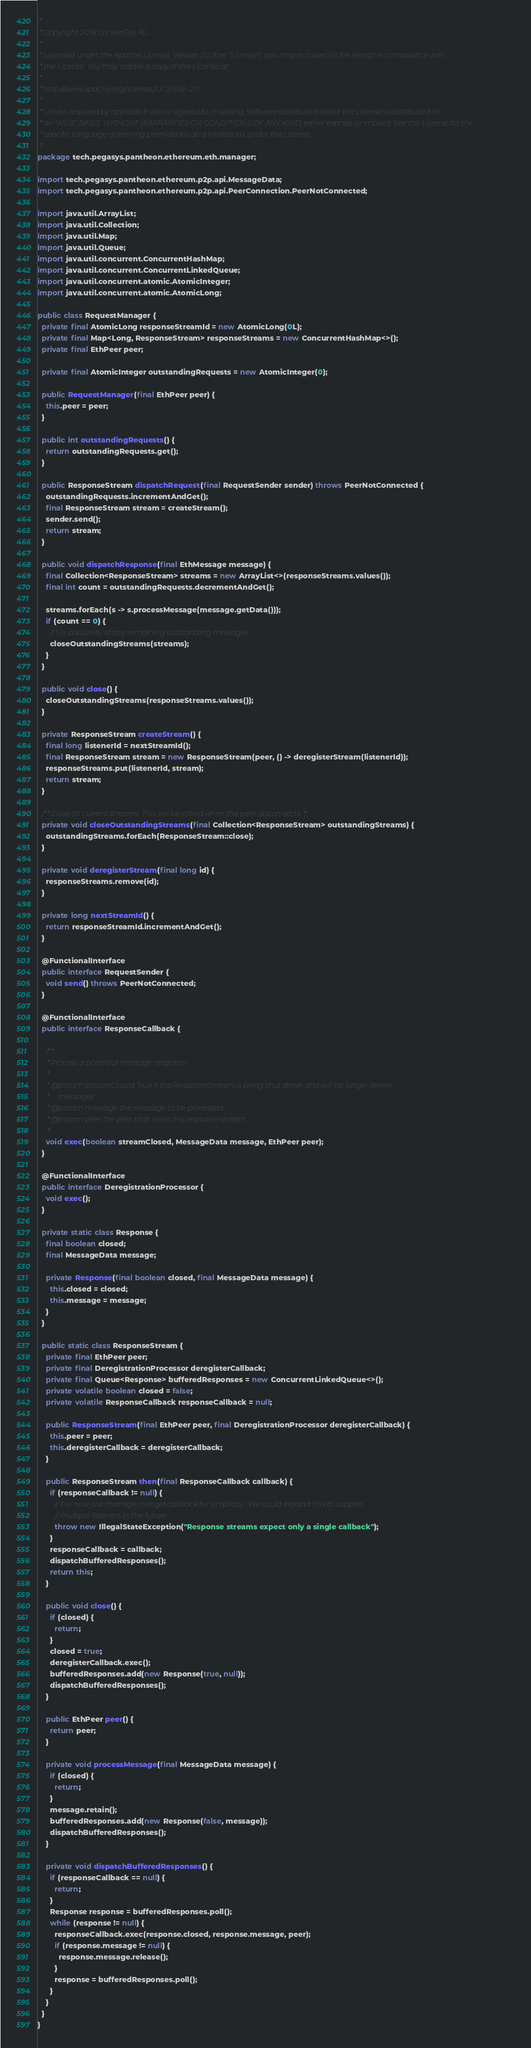<code> <loc_0><loc_0><loc_500><loc_500><_Java_>/*
 * Copyright 2018 ConsenSys AG.
 *
 * Licensed under the Apache License, Version 2.0 (the "License"); you may not use this file except in compliance with
 * the License. You may obtain a copy of the License at
 *
 * http://www.apache.org/licenses/LICENSE-2.0
 *
 * Unless required by applicable law or agreed to in writing, software distributed under the License is distributed on
 * an "AS IS" BASIS, WITHOUT WARRANTIES OR CONDITIONS OF ANY KIND, either express or implied. See the License for the
 * specific language governing permissions and limitations under the License.
 */
package tech.pegasys.pantheon.ethereum.eth.manager;

import tech.pegasys.pantheon.ethereum.p2p.api.MessageData;
import tech.pegasys.pantheon.ethereum.p2p.api.PeerConnection.PeerNotConnected;

import java.util.ArrayList;
import java.util.Collection;
import java.util.Map;
import java.util.Queue;
import java.util.concurrent.ConcurrentHashMap;
import java.util.concurrent.ConcurrentLinkedQueue;
import java.util.concurrent.atomic.AtomicInteger;
import java.util.concurrent.atomic.AtomicLong;

public class RequestManager {
  private final AtomicLong responseStreamId = new AtomicLong(0L);
  private final Map<Long, ResponseStream> responseStreams = new ConcurrentHashMap<>();
  private final EthPeer peer;

  private final AtomicInteger outstandingRequests = new AtomicInteger(0);

  public RequestManager(final EthPeer peer) {
    this.peer = peer;
  }

  public int outstandingRequests() {
    return outstandingRequests.get();
  }

  public ResponseStream dispatchRequest(final RequestSender sender) throws PeerNotConnected {
    outstandingRequests.incrementAndGet();
    final ResponseStream stream = createStream();
    sender.send();
    return stream;
  }

  public void dispatchResponse(final EthMessage message) {
    final Collection<ResponseStream> streams = new ArrayList<>(responseStreams.values());
    final int count = outstandingRequests.decrementAndGet();

    streams.forEach(s -> s.processMessage(message.getData()));
    if (count == 0) {
      // No possibility of any remaining outstanding messages
      closeOutstandingStreams(streams);
    }
  }

  public void close() {
    closeOutstandingStreams(responseStreams.values());
  }

  private ResponseStream createStream() {
    final long listenerId = nextStreamId();
    final ResponseStream stream = new ResponseStream(peer, () -> deregisterStream(listenerId));
    responseStreams.put(listenerId, stream);
    return stream;
  }

  /** Close all current streams. This will be called when the peer disconnects. */
  private void closeOutstandingStreams(final Collection<ResponseStream> outstandingStreams) {
    outstandingStreams.forEach(ResponseStream::close);
  }

  private void deregisterStream(final long id) {
    responseStreams.remove(id);
  }

  private long nextStreamId() {
    return responseStreamId.incrementAndGet();
  }

  @FunctionalInterface
  public interface RequestSender {
    void send() throws PeerNotConnected;
  }

  @FunctionalInterface
  public interface ResponseCallback {

    /**
     * Process a potential message response
     *
     * @param streamClosed True if the ResponseStream is being shut down and will no longer deliver
     *     messages.
     * @param message the message to be processed
     * @param peer the peer that owns this response stream
     */
    void exec(boolean streamClosed, MessageData message, EthPeer peer);
  }

  @FunctionalInterface
  public interface DeregistrationProcessor {
    void exec();
  }

  private static class Response {
    final boolean closed;
    final MessageData message;

    private Response(final boolean closed, final MessageData message) {
      this.closed = closed;
      this.message = message;
    }
  }

  public static class ResponseStream {
    private final EthPeer peer;
    private final DeregistrationProcessor deregisterCallback;
    private final Queue<Response> bufferedResponses = new ConcurrentLinkedQueue<>();
    private volatile boolean closed = false;
    private volatile ResponseCallback responseCallback = null;

    public ResponseStream(final EthPeer peer, final DeregistrationProcessor deregisterCallback) {
      this.peer = peer;
      this.deregisterCallback = deregisterCallback;
    }

    public ResponseStream then(final ResponseCallback callback) {
      if (responseCallback != null) {
        // For now just manage a single callback for simplicity.  We could expand this to support
        // multiple listeners in the future.
        throw new IllegalStateException("Response streams expect only a single callback");
      }
      responseCallback = callback;
      dispatchBufferedResponses();
      return this;
    }

    public void close() {
      if (closed) {
        return;
      }
      closed = true;
      deregisterCallback.exec();
      bufferedResponses.add(new Response(true, null));
      dispatchBufferedResponses();
    }

    public EthPeer peer() {
      return peer;
    }

    private void processMessage(final MessageData message) {
      if (closed) {
        return;
      }
      message.retain();
      bufferedResponses.add(new Response(false, message));
      dispatchBufferedResponses();
    }

    private void dispatchBufferedResponses() {
      if (responseCallback == null) {
        return;
      }
      Response response = bufferedResponses.poll();
      while (response != null) {
        responseCallback.exec(response.closed, response.message, peer);
        if (response.message != null) {
          response.message.release();
        }
        response = bufferedResponses.poll();
      }
    }
  }
}
</code> 